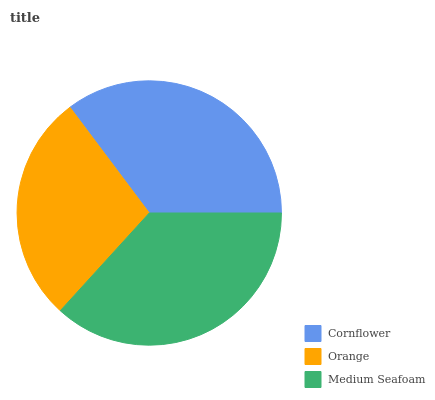Is Orange the minimum?
Answer yes or no. Yes. Is Medium Seafoam the maximum?
Answer yes or no. Yes. Is Medium Seafoam the minimum?
Answer yes or no. No. Is Orange the maximum?
Answer yes or no. No. Is Medium Seafoam greater than Orange?
Answer yes or no. Yes. Is Orange less than Medium Seafoam?
Answer yes or no. Yes. Is Orange greater than Medium Seafoam?
Answer yes or no. No. Is Medium Seafoam less than Orange?
Answer yes or no. No. Is Cornflower the high median?
Answer yes or no. Yes. Is Cornflower the low median?
Answer yes or no. Yes. Is Orange the high median?
Answer yes or no. No. Is Medium Seafoam the low median?
Answer yes or no. No. 